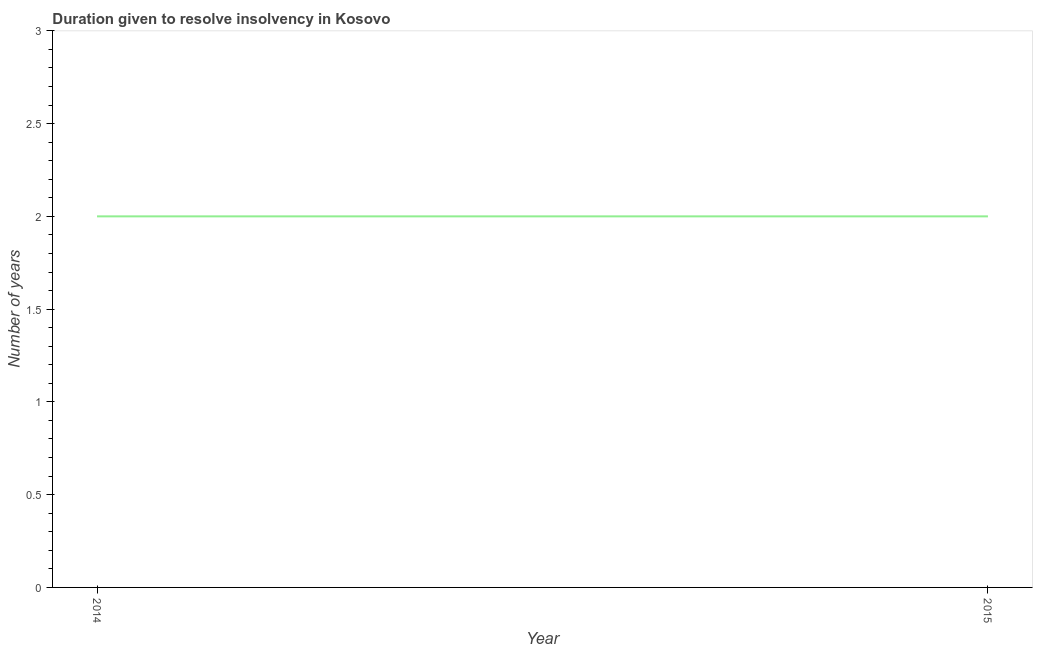What is the number of years to resolve insolvency in 2015?
Provide a short and direct response. 2. Across all years, what is the maximum number of years to resolve insolvency?
Offer a terse response. 2. Across all years, what is the minimum number of years to resolve insolvency?
Your answer should be compact. 2. In which year was the number of years to resolve insolvency minimum?
Offer a very short reply. 2014. What is the sum of the number of years to resolve insolvency?
Provide a succinct answer. 4. In how many years, is the number of years to resolve insolvency greater than 0.9 ?
Offer a very short reply. 2. What is the ratio of the number of years to resolve insolvency in 2014 to that in 2015?
Your response must be concise. 1. Is the number of years to resolve insolvency in 2014 less than that in 2015?
Provide a short and direct response. No. In how many years, is the number of years to resolve insolvency greater than the average number of years to resolve insolvency taken over all years?
Make the answer very short. 0. Does the graph contain any zero values?
Your answer should be compact. No. What is the title of the graph?
Your answer should be very brief. Duration given to resolve insolvency in Kosovo. What is the label or title of the X-axis?
Your response must be concise. Year. What is the label or title of the Y-axis?
Offer a very short reply. Number of years. What is the difference between the Number of years in 2014 and 2015?
Your response must be concise. 0. 